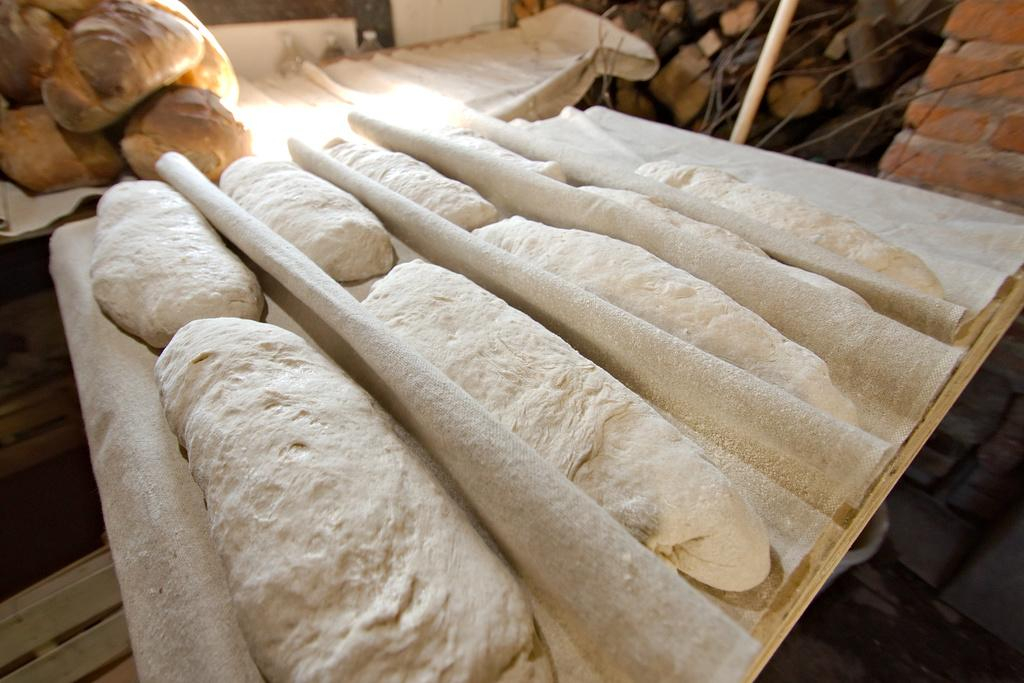What types of items can be seen in the image? There are clothes, food items, bottles, wooden logs, and a pole in the image. What else can be found in the image? There is a wall and some unspecified objects in the image. Can you describe the wooden logs in the image? The wooden logs are likely used for fuel or decoration. What might the unspecified objects be used for? It is difficult to determine their purpose without more information, but they could be tools, toys, or other household items. How many cannons are present in the image? There are no cannons present in the image. What type of seed can be seen growing near the wooden logs? There is no seed visible in the image. 